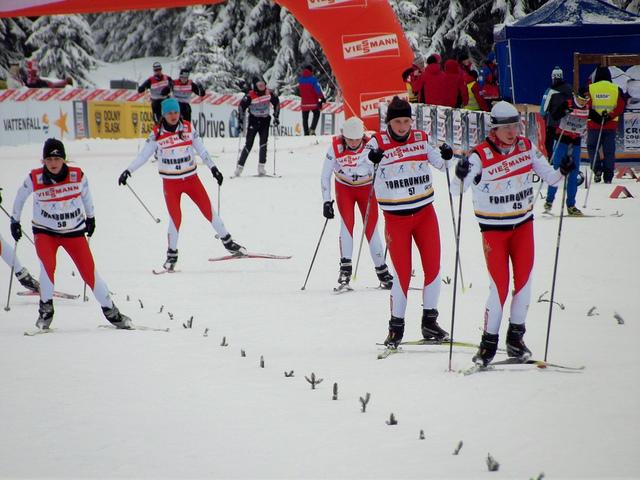Are these people competing or doing this for leisure?
Be succinct. Competing. Is there snow on the trees?
Write a very short answer. Yes. Are any of these guys related?
Quick response, please. No. What covers the ground?
Keep it brief. Snow. What number is the rightmost skier?
Answer briefly. 45. 